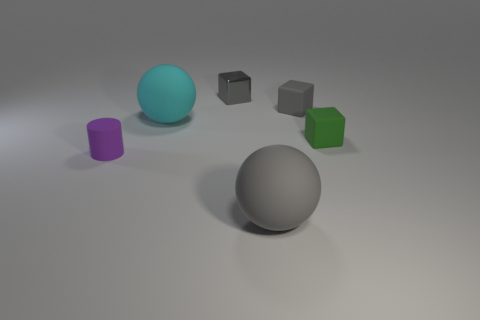Are there any large matte balls of the same color as the tiny shiny cube?
Provide a short and direct response. Yes. Is the color of the metallic block the same as the large rubber object in front of the large cyan thing?
Make the answer very short. Yes. Are there any small rubber cylinders to the left of the big matte sphere on the left side of the rubber sphere that is in front of the small purple cylinder?
Give a very brief answer. Yes. What color is the cylinder that is made of the same material as the small green thing?
Provide a short and direct response. Purple. Are the tiny green cube and the tiny gray object to the left of the gray rubber sphere made of the same material?
Provide a succinct answer. No. There is a gray matte ball to the left of the gray thing right of the large ball in front of the matte cylinder; how big is it?
Make the answer very short. Large. There is a ball that is the same color as the shiny block; what is it made of?
Offer a very short reply. Rubber. Are there any other things that have the same shape as the large gray thing?
Your answer should be compact. Yes. What size is the rubber object behind the sphere behind the tiny purple matte cylinder?
Your response must be concise. Small. What number of cyan rubber balls are behind the rubber ball behind the large gray thing?
Give a very brief answer. 0. 